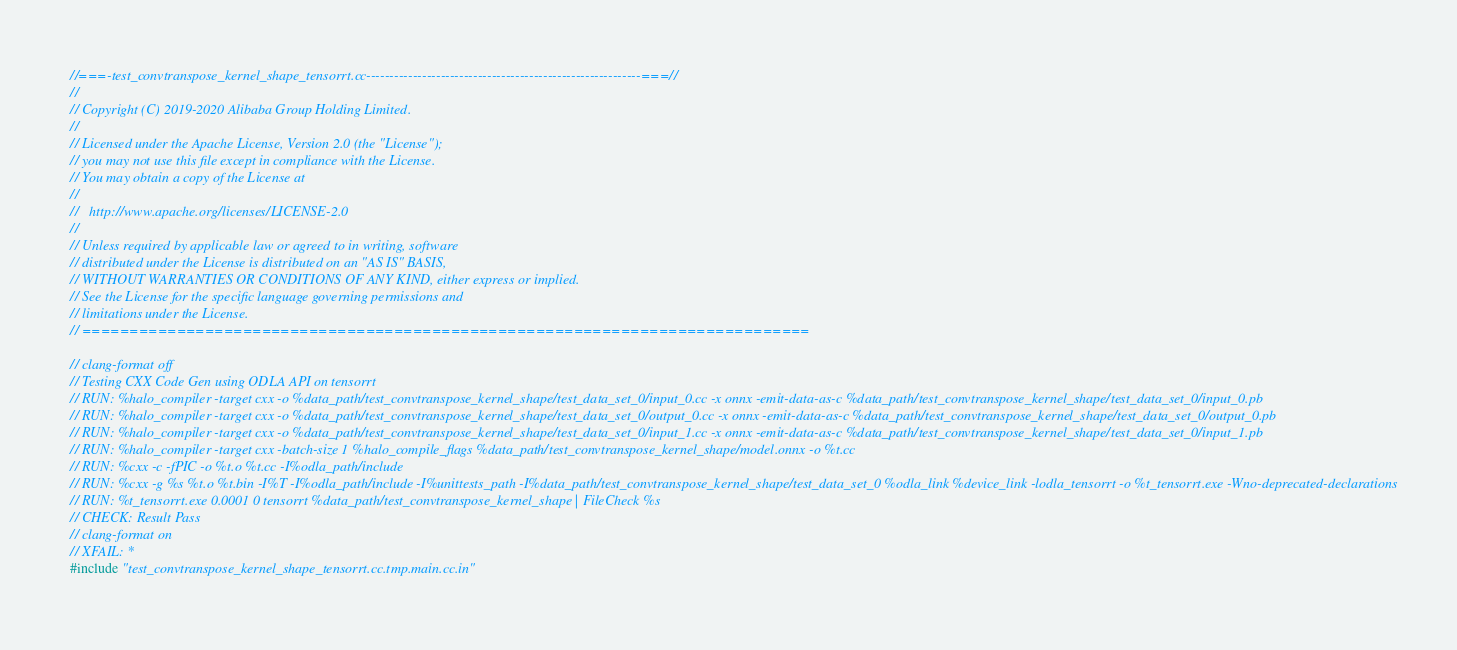<code> <loc_0><loc_0><loc_500><loc_500><_C++_>//===-test_convtranspose_kernel_shape_tensorrt.cc-----------------------------------------------------------===//
//
// Copyright (C) 2019-2020 Alibaba Group Holding Limited.
//
// Licensed under the Apache License, Version 2.0 (the "License");
// you may not use this file except in compliance with the License.
// You may obtain a copy of the License at
//
//   http://www.apache.org/licenses/LICENSE-2.0
//
// Unless required by applicable law or agreed to in writing, software
// distributed under the License is distributed on an "AS IS" BASIS,
// WITHOUT WARRANTIES OR CONDITIONS OF ANY KIND, either express or implied.
// See the License for the specific language governing permissions and
// limitations under the License.
// =============================================================================

// clang-format off
// Testing CXX Code Gen using ODLA API on tensorrt
// RUN: %halo_compiler -target cxx -o %data_path/test_convtranspose_kernel_shape/test_data_set_0/input_0.cc -x onnx -emit-data-as-c %data_path/test_convtranspose_kernel_shape/test_data_set_0/input_0.pb
// RUN: %halo_compiler -target cxx -o %data_path/test_convtranspose_kernel_shape/test_data_set_0/output_0.cc -x onnx -emit-data-as-c %data_path/test_convtranspose_kernel_shape/test_data_set_0/output_0.pb
// RUN: %halo_compiler -target cxx -o %data_path/test_convtranspose_kernel_shape/test_data_set_0/input_1.cc -x onnx -emit-data-as-c %data_path/test_convtranspose_kernel_shape/test_data_set_0/input_1.pb
// RUN: %halo_compiler -target cxx -batch-size 1 %halo_compile_flags %data_path/test_convtranspose_kernel_shape/model.onnx -o %t.cc
// RUN: %cxx -c -fPIC -o %t.o %t.cc -I%odla_path/include
// RUN: %cxx -g %s %t.o %t.bin -I%T -I%odla_path/include -I%unittests_path -I%data_path/test_convtranspose_kernel_shape/test_data_set_0 %odla_link %device_link -lodla_tensorrt -o %t_tensorrt.exe -Wno-deprecated-declarations
// RUN: %t_tensorrt.exe 0.0001 0 tensorrt %data_path/test_convtranspose_kernel_shape | FileCheck %s
// CHECK: Result Pass
// clang-format on
// XFAIL: *
#include "test_convtranspose_kernel_shape_tensorrt.cc.tmp.main.cc.in"
</code> 